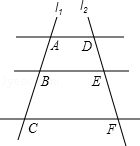If this image were to be part of a math problem, what question might it be associated with? If this image were part of a math problem, it might ask for determining the measures of angles formed by the intersecting lines, calculating the slopes of l1 and l2 if considered as linear functions, or using the intercepts to define equations for the lines. Another question might involve proving theorems related to the properties of parallel lines cut by a transversal, such as demonstrating that alternate interior angles are equal. 